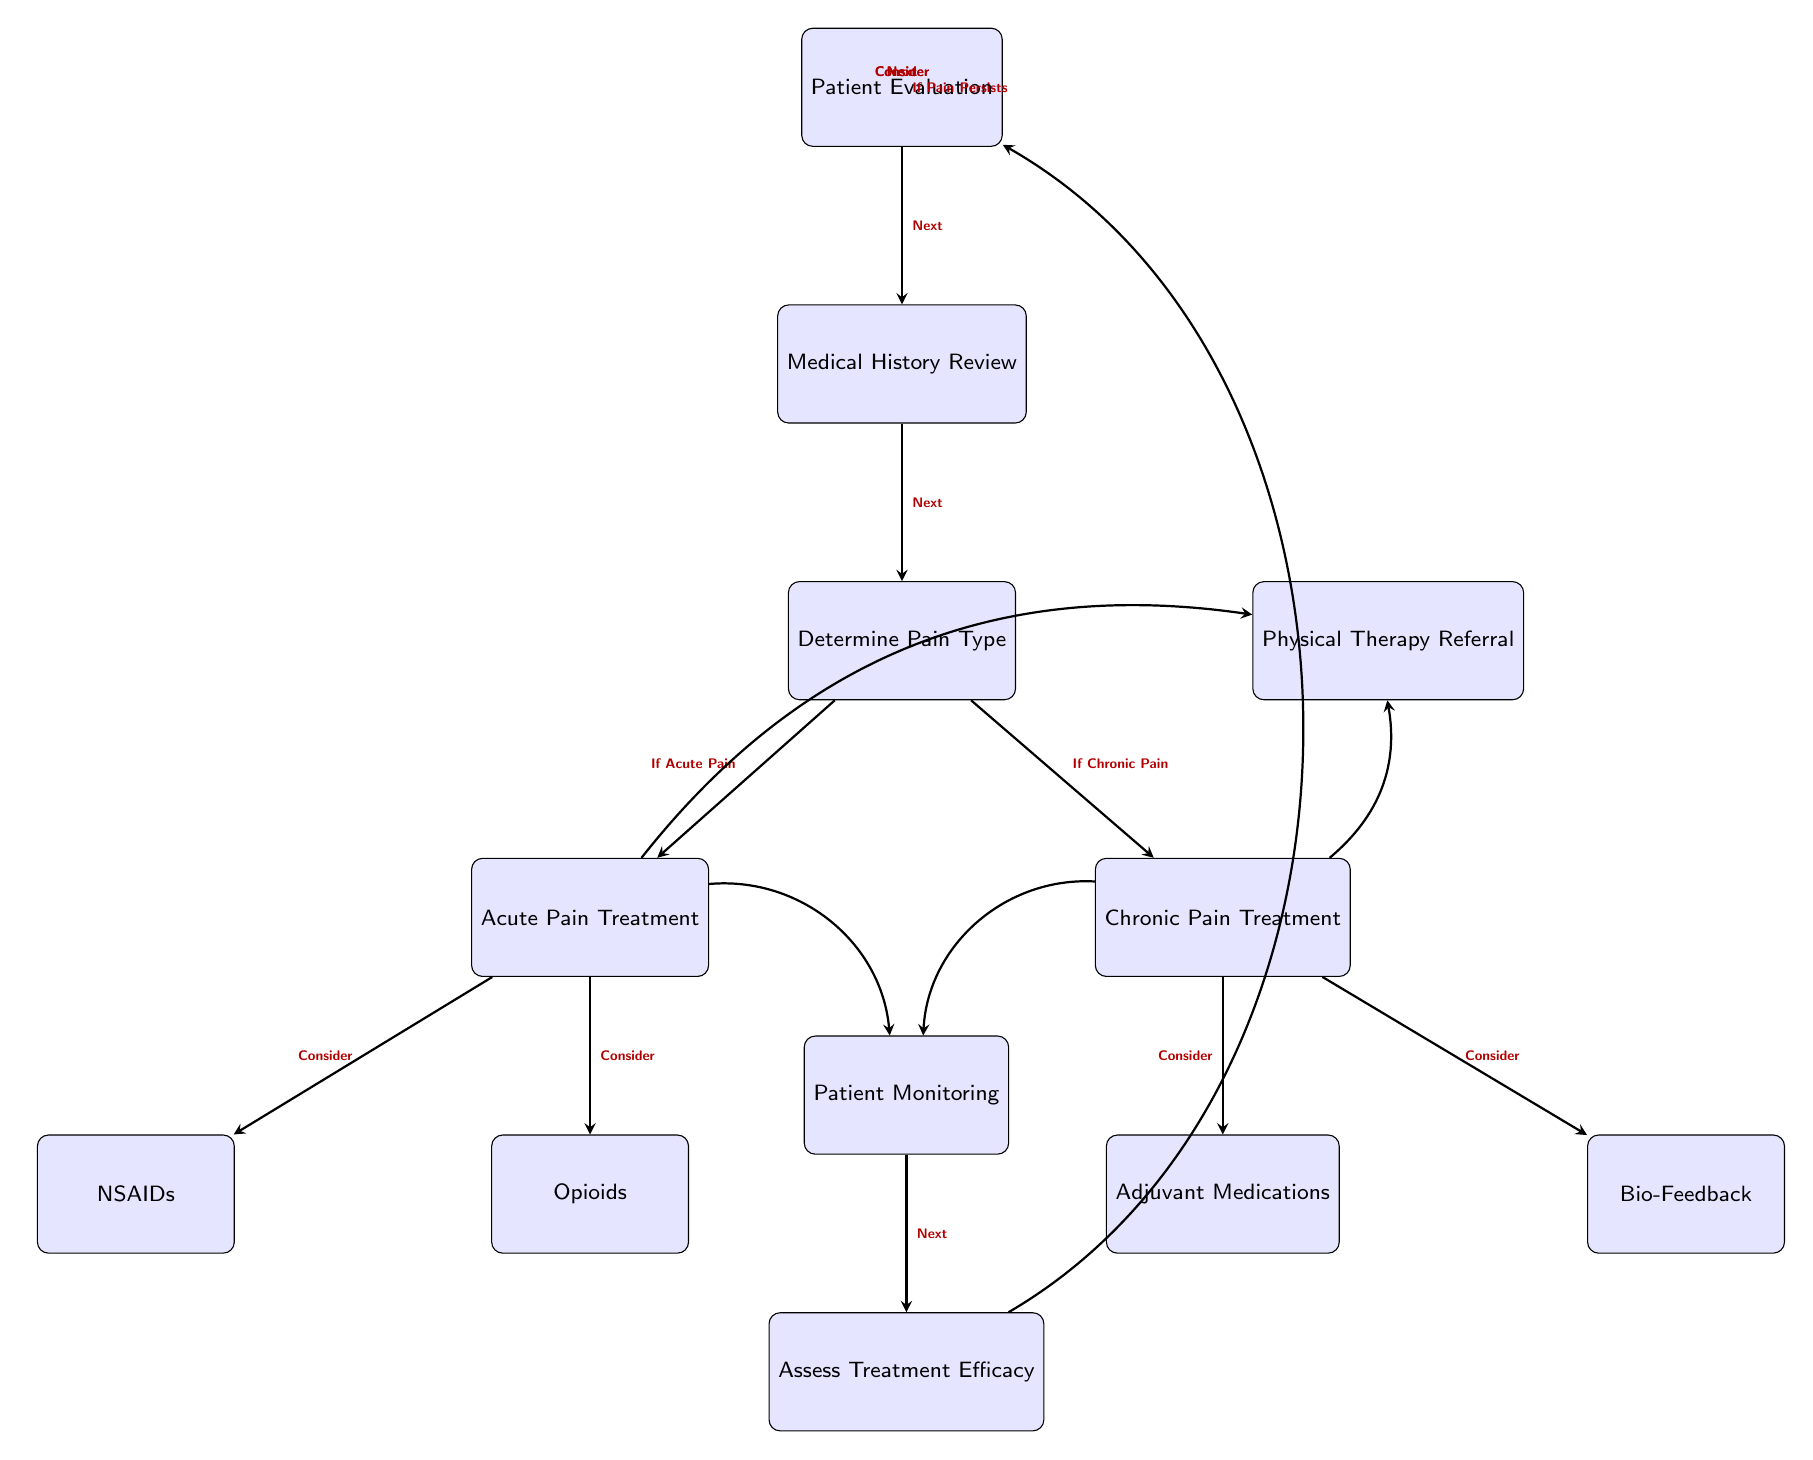What is the first step in the decision-making process? The first step, as indicated by the topmost node in the diagram, is "Patient Evaluation."
Answer: Patient Evaluation How many treatment options are considered for acute pain? There are two treatment options mentioned for acute pain: "NSAIDs" and "Opioids."
Answer: 2 What follows after determining the pain type? After determining the pain type, the next steps are to treat either acute pain or chronic pain, represented by the branches leading to "Acute Pain Treatment" and "Chronic Pain Treatment."
Answer: Physical Therapy Referral What medication is associated with chronic pain treatment? The medication referenced for chronic pain treatment is "Adjuvant Medications."
Answer: Adjuvant Medications What happens after the patient monitoring step? After patient monitoring, the next step is to "Assess Treatment Efficacy."
Answer: Assess Treatment Efficacy If a patient is experiencing acute pain, which treatment option is suggested first? The first treatment option suggested for acute pain is "NSAIDs."
Answer: NSAIDs What type of therapy is suggested alongside medication treatments? The diagram suggests a "Physical Therapy Referral" alongside medication treatments.
Answer: Physical Therapy Referral How are opioids categorized in the decision-making process? Opioids are categorized as a treatment option for "Acute Pain Treatment."
Answer: Acute Pain Treatment What is the role of the "Patient Monitoring" node in the diagram? The "Patient Monitoring" node checks on the effectiveness of the treatment and leads to "Assess Treatment Efficacy."
Answer: Assess Treatment Efficacy 